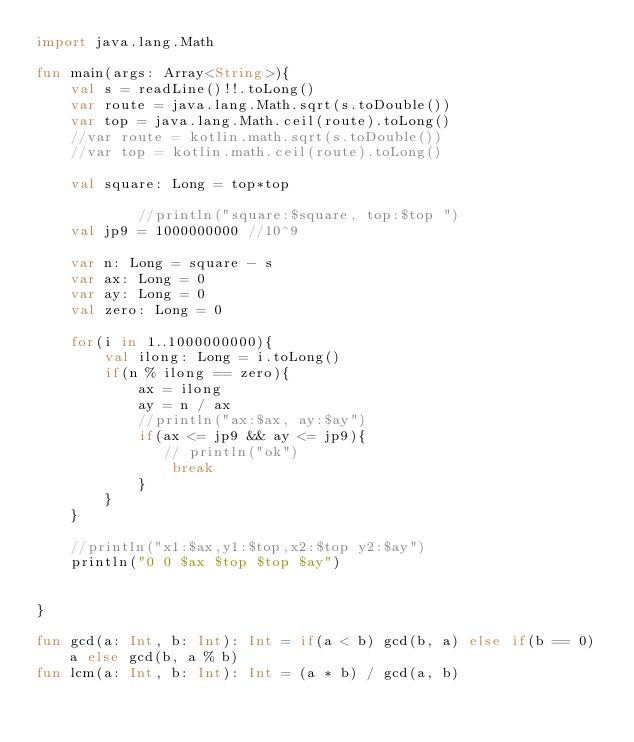<code> <loc_0><loc_0><loc_500><loc_500><_Kotlin_>import java.lang.Math

fun main(args: Array<String>){
    val s = readLine()!!.toLong()
    var route = java.lang.Math.sqrt(s.toDouble())
    var top = java.lang.Math.ceil(route).toLong()
    //var route = kotlin.math.sqrt(s.toDouble())
    //var top = kotlin.math.ceil(route).toLong()

    val square: Long = top*top

            //println("square:$square, top:$top ")
    val jp9 = 1000000000 //10^9

    var n: Long = square - s
    var ax: Long = 0
    var ay: Long = 0
    val zero: Long = 0

    for(i in 1..1000000000){
        val ilong: Long = i.toLong()
        if(n % ilong == zero){
            ax = ilong
            ay = n / ax
            //println("ax:$ax, ay:$ay")
            if(ax <= jp9 && ay <= jp9){
               // println("ok")
                break
            }
        }
    }

    //println("x1:$ax,y1:$top,x2:$top y2:$ay")
    println("0 0 $ax $top $top $ay")


}

fun gcd(a: Int, b: Int): Int = if(a < b) gcd(b, a) else if(b == 0) a else gcd(b, a % b)
fun lcm(a: Int, b: Int): Int = (a * b) / gcd(a, b)</code> 